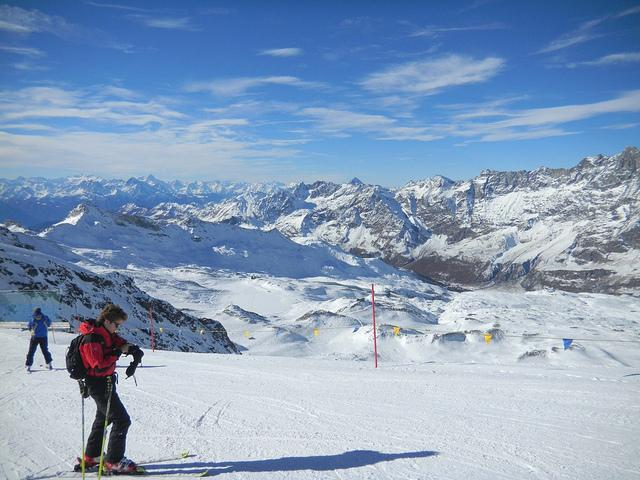Where is the sun with respect to the person wearing red coat?

Choices:
A) front
B) right
C) left
D) back back 